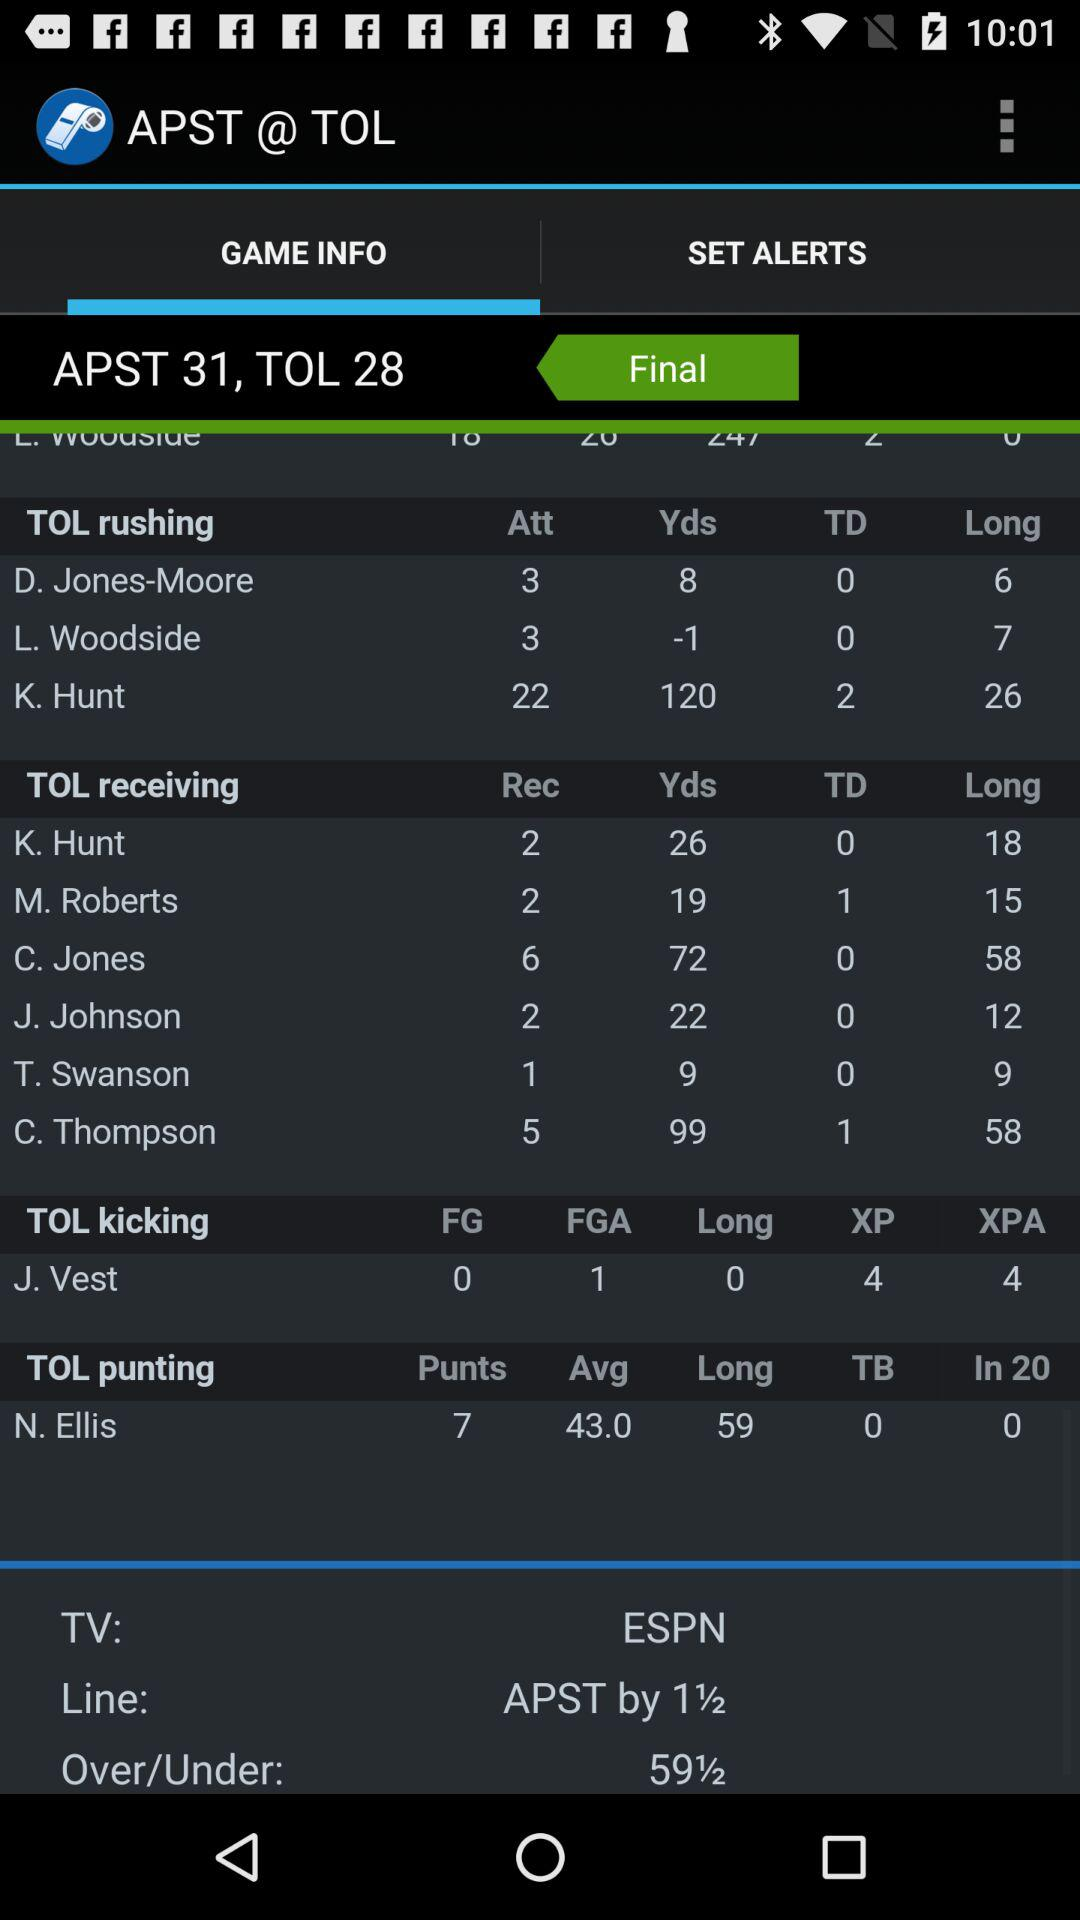Which tab is currently selected? The currently selected tab is "GAME INFO". 